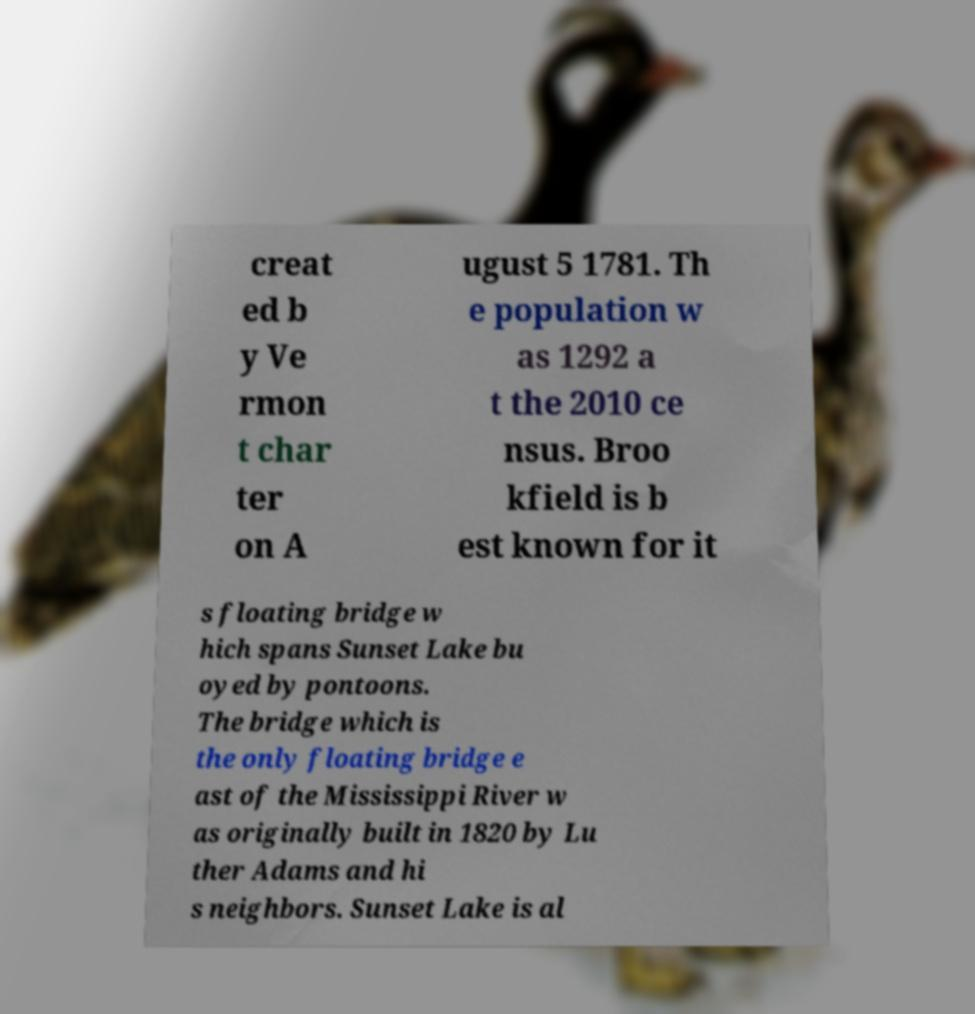For documentation purposes, I need the text within this image transcribed. Could you provide that? creat ed b y Ve rmon t char ter on A ugust 5 1781. Th e population w as 1292 a t the 2010 ce nsus. Broo kfield is b est known for it s floating bridge w hich spans Sunset Lake bu oyed by pontoons. The bridge which is the only floating bridge e ast of the Mississippi River w as originally built in 1820 by Lu ther Adams and hi s neighbors. Sunset Lake is al 